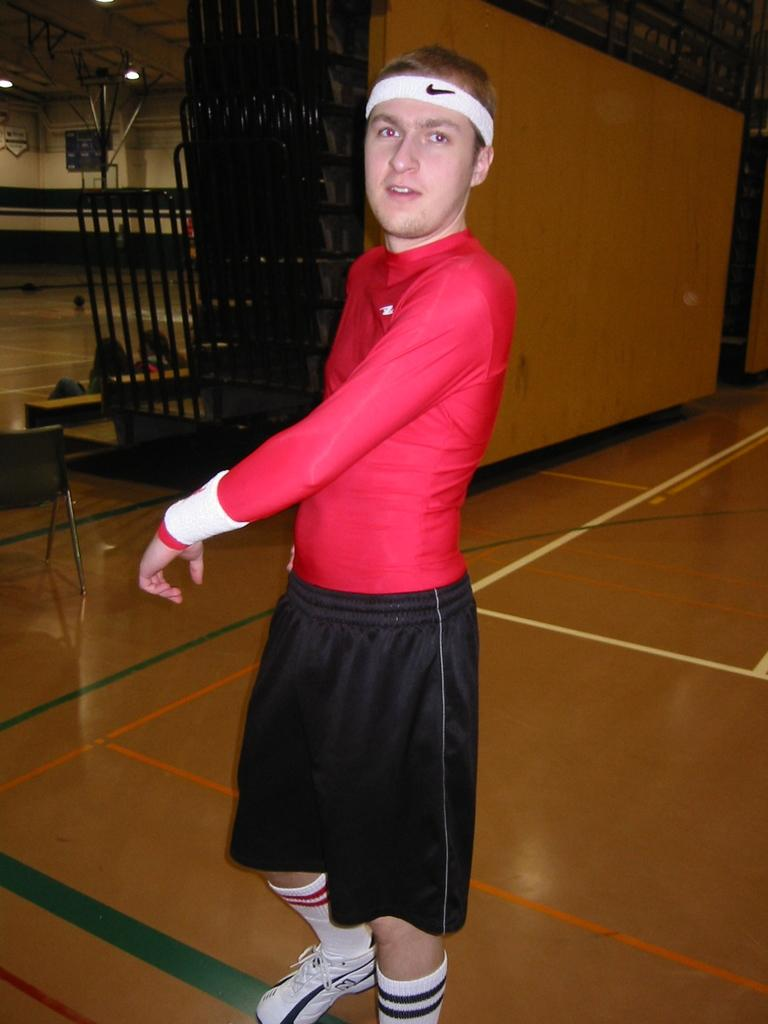What is the primary subject in the image? There is a person standing in the image. What can be seen in the background of the image? There are grills, walls, lights, a chair, and people in the background of the image. Can you describe the setting of the image? The image appears to be set in an outdoor area with grills, walls, and lights, and there are people in the background. What type of book is the person reading in the image? There is no book present in the image; the person is standing and not reading. How many horses are visible in the image? There are no horses present in the image. 